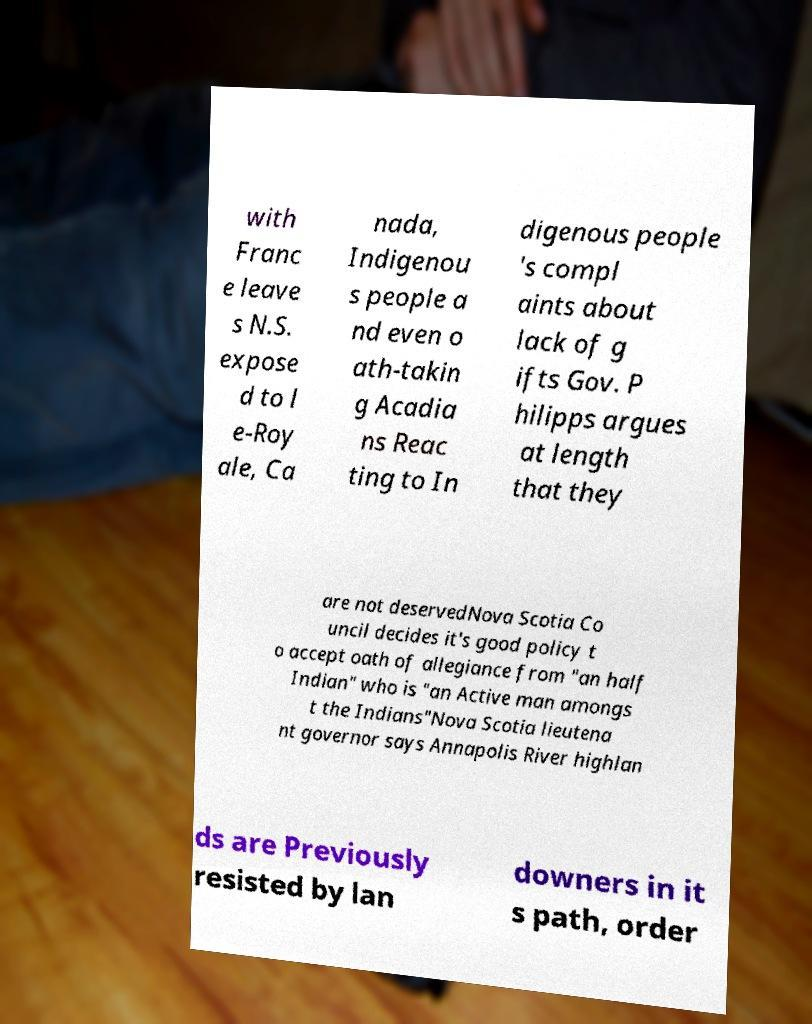Can you read and provide the text displayed in the image?This photo seems to have some interesting text. Can you extract and type it out for me? with Franc e leave s N.S. expose d to l e-Roy ale, Ca nada, Indigenou s people a nd even o ath-takin g Acadia ns Reac ting to In digenous people 's compl aints about lack of g ifts Gov. P hilipps argues at length that they are not deservedNova Scotia Co uncil decides it's good policy t o accept oath of allegiance from "an half Indian" who is "an Active man amongs t the Indians"Nova Scotia lieutena nt governor says Annapolis River highlan ds are Previously resisted by lan downers in it s path, order 